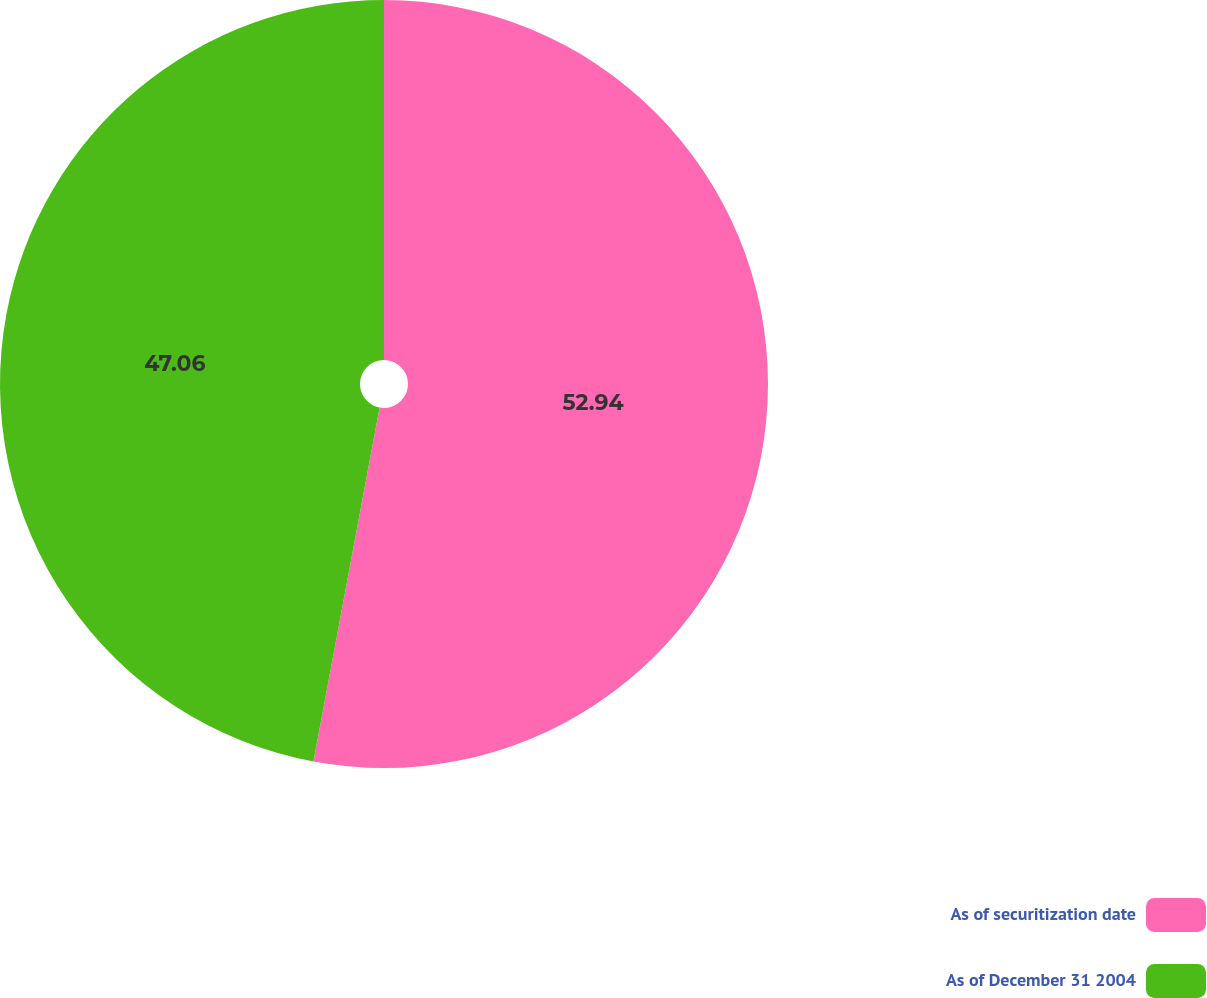Convert chart. <chart><loc_0><loc_0><loc_500><loc_500><pie_chart><fcel>As of securitization date<fcel>As of December 31 2004<nl><fcel>52.94%<fcel>47.06%<nl></chart> 